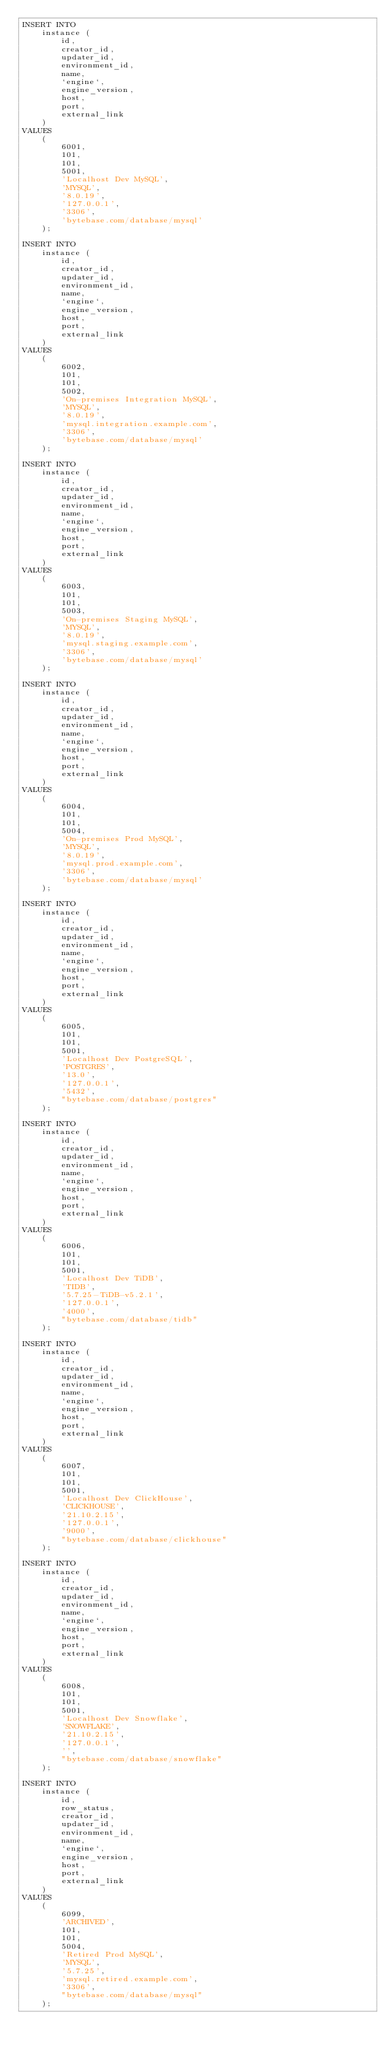Convert code to text. <code><loc_0><loc_0><loc_500><loc_500><_SQL_>INSERT INTO
    instance (
        id,
        creator_id,
        updater_id,
        environment_id,
        name,
        `engine`,
        engine_version,
        host,
        port,
        external_link
    )
VALUES
    (
        6001,
        101,
        101,
        5001,
        'Localhost Dev MySQL',
        'MYSQL',
        '8.0.19',
        '127.0.0.1',
        '3306',
        'bytebase.com/database/mysql'
    );

INSERT INTO
    instance (
        id,
        creator_id,
        updater_id,
        environment_id,
        name,
        `engine`,
        engine_version,
        host,
        port,
        external_link
    )
VALUES
    (
        6002,
        101,
        101,
        5002,
        'On-premises Integration MySQL',
        'MYSQL',
        '8.0.19',
        'mysql.integration.example.com',
        '3306',
        'bytebase.com/database/mysql'
    );

INSERT INTO
    instance (
        id,
        creator_id,
        updater_id,
        environment_id,
        name,
        `engine`,
        engine_version,
        host,
        port,
        external_link
    )
VALUES
    (
        6003,
        101,
        101,
        5003,
        'On-premises Staging MySQL',
        'MYSQL',
        '8.0.19',
        'mysql.staging.example.com',
        '3306',
        'bytebase.com/database/mysql'
    );

INSERT INTO
    instance (
        id,
        creator_id,
        updater_id,
        environment_id,
        name,
        `engine`,
        engine_version,
        host,
        port,
        external_link
    )
VALUES
    (
        6004,
        101,
        101,
        5004,
        'On-premises Prod MySQL',
        'MYSQL',
        '8.0.19',
        'mysql.prod.example.com',
        '3306',
        'bytebase.com/database/mysql'
    );

INSERT INTO
    instance (
        id,
        creator_id,
        updater_id,
        environment_id,
        name,
        `engine`,
        engine_version,
        host,
        port,
        external_link
    )
VALUES
    (
        6005,
        101,
        101,
        5001,
        'Localhost Dev PostgreSQL',
        'POSTGRES',
        '13.0',
        '127.0.0.1',
        '5432',
        "bytebase.com/database/postgres"
    );

INSERT INTO
    instance (
        id,
        creator_id,
        updater_id,
        environment_id,
        name,
        `engine`,
        engine_version,
        host,
        port,
        external_link
    )
VALUES
    (
        6006,
        101,
        101,
        5001,
        'Localhost Dev TiDB',
        'TIDB',
        '5.7.25-TiDB-v5.2.1',
        '127.0.0.1',
        '4000',
        "bytebase.com/database/tidb"
    );

INSERT INTO
    instance (
        id,
        creator_id,
        updater_id,
        environment_id,
        name,
        `engine`,
        engine_version,
        host,
        port,
        external_link
    )
VALUES
    (
        6007,
        101,
        101,
        5001,
        'Localhost Dev ClickHouse',
        'CLICKHOUSE',
        '21.10.2.15',
        '127.0.0.1',
        '9000',
        "bytebase.com/database/clickhouse"
    );

INSERT INTO
    instance (
        id,
        creator_id,
        updater_id,
        environment_id,
        name,
        `engine`,
        engine_version,
        host,
        port,
        external_link
    )
VALUES
    (
        6008,
        101,
        101,
        5001,
        'Localhost Dev Snowflake',
        'SNOWFLAKE',
        '21.10.2.15',
        '127.0.0.1',
        '',
        "bytebase.com/database/snowflake"
    );

INSERT INTO
    instance (
        id,
        row_status,
        creator_id,
        updater_id,
        environment_id,
        name,
        `engine`,
        engine_version,
        host,
        port,
        external_link
    )
VALUES
    (
        6099,
        'ARCHIVED',
        101,
        101,
        5004,
        'Retired Prod MySQL',
        'MYSQL',
        '5.7.25',
        'mysql.retired.example.com',
        '3306',
        "bytebase.com/database/mysql"
    );
</code> 